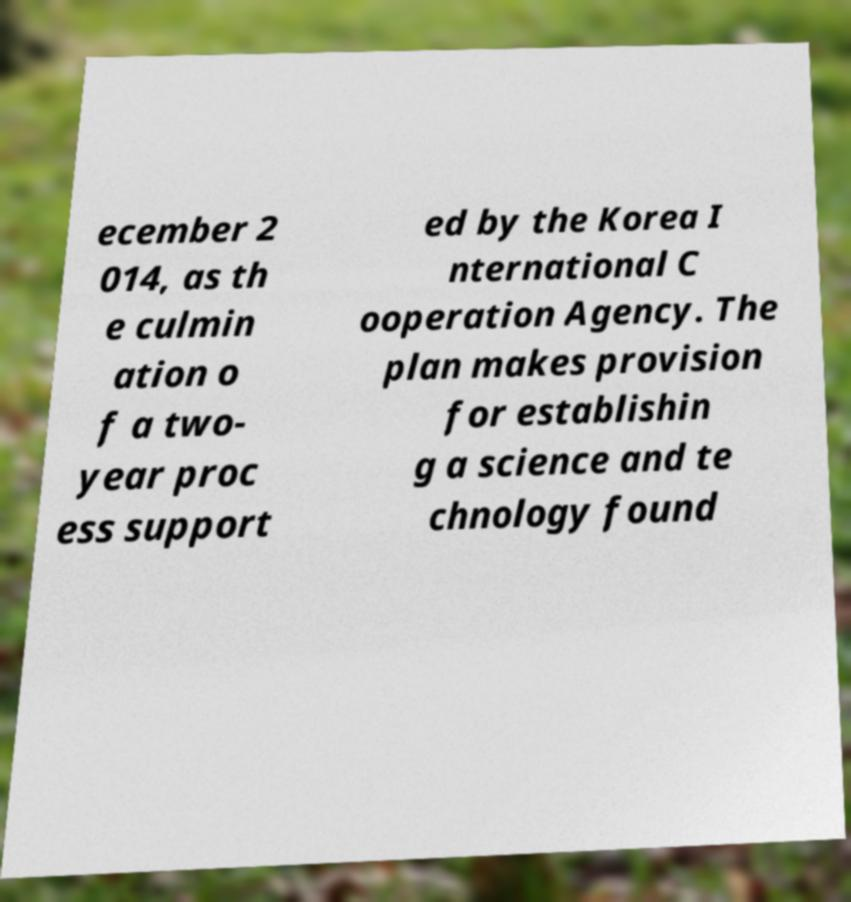For documentation purposes, I need the text within this image transcribed. Could you provide that? ecember 2 014, as th e culmin ation o f a two- year proc ess support ed by the Korea I nternational C ooperation Agency. The plan makes provision for establishin g a science and te chnology found 